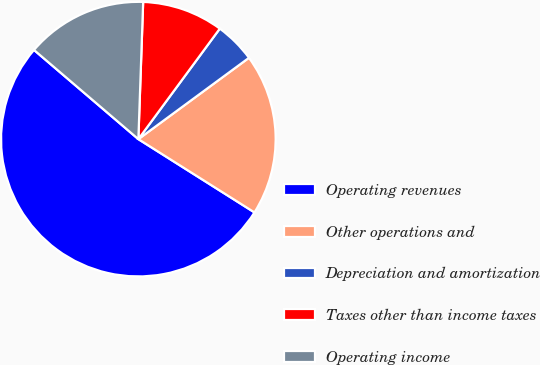<chart> <loc_0><loc_0><loc_500><loc_500><pie_chart><fcel>Operating revenues<fcel>Other operations and<fcel>Depreciation and amortization<fcel>Taxes other than income taxes<fcel>Operating income<nl><fcel>52.29%<fcel>19.05%<fcel>4.8%<fcel>9.55%<fcel>14.3%<nl></chart> 